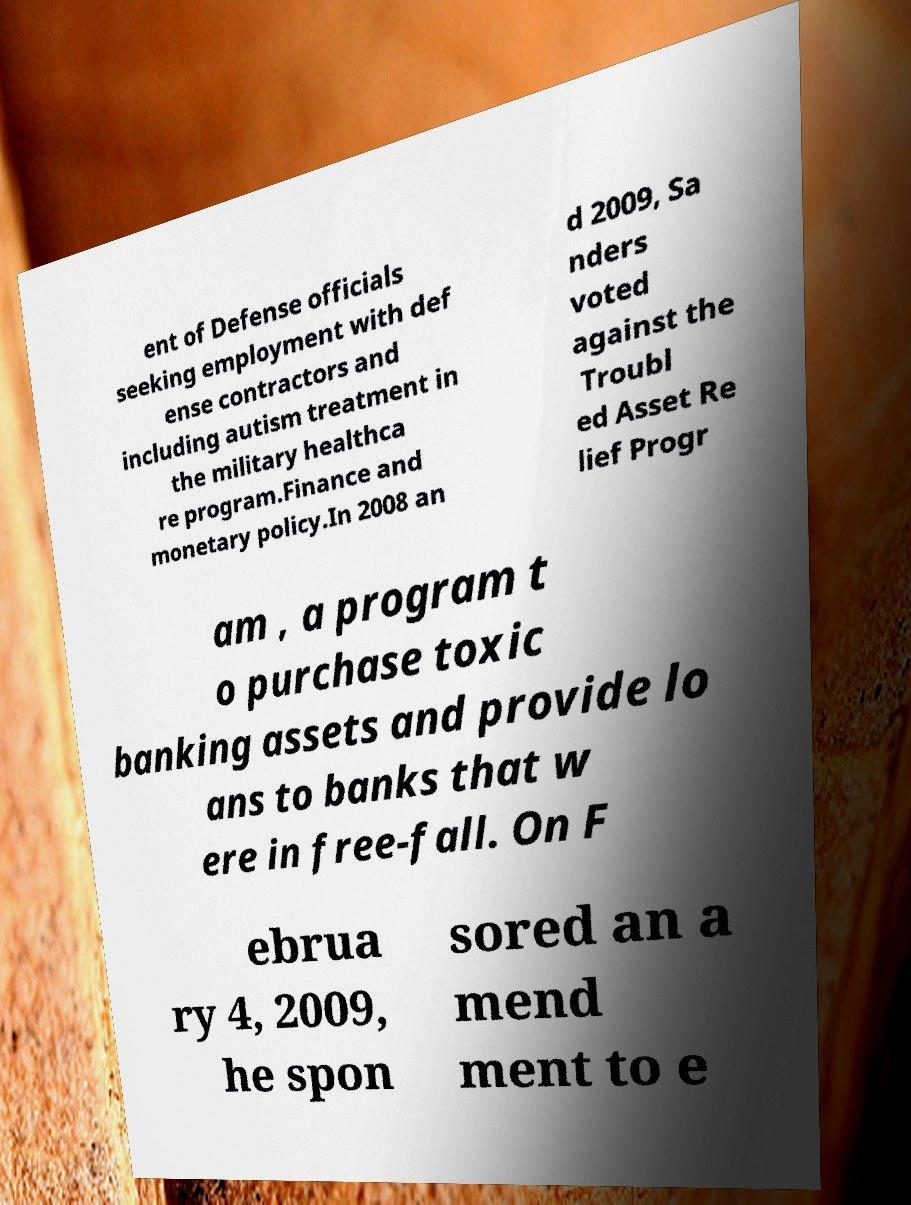Could you assist in decoding the text presented in this image and type it out clearly? ent of Defense officials seeking employment with def ense contractors and including autism treatment in the military healthca re program.Finance and monetary policy.In 2008 an d 2009, Sa nders voted against the Troubl ed Asset Re lief Progr am , a program t o purchase toxic banking assets and provide lo ans to banks that w ere in free-fall. On F ebrua ry 4, 2009, he spon sored an a mend ment to e 